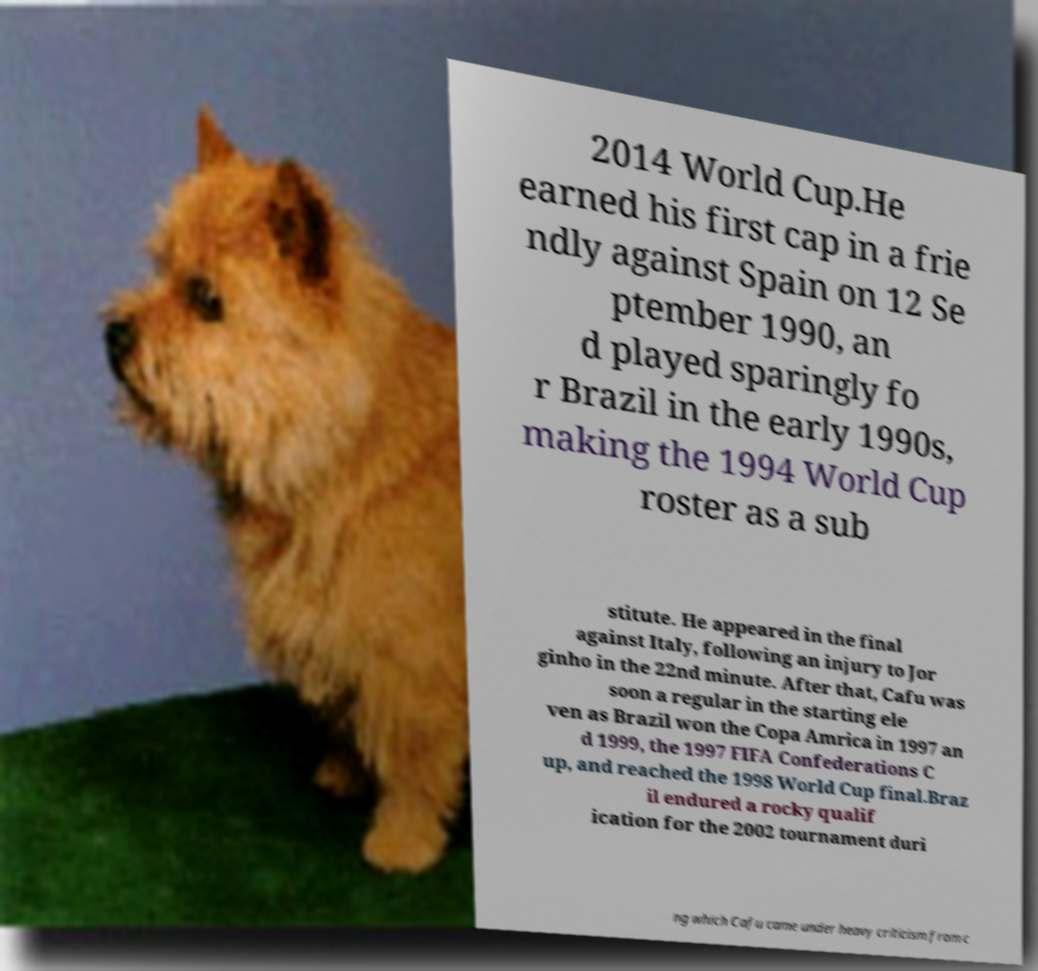I need the written content from this picture converted into text. Can you do that? 2014 World Cup.He earned his first cap in a frie ndly against Spain on 12 Se ptember 1990, an d played sparingly fo r Brazil in the early 1990s, making the 1994 World Cup roster as a sub stitute. He appeared in the final against Italy, following an injury to Jor ginho in the 22nd minute. After that, Cafu was soon a regular in the starting ele ven as Brazil won the Copa Amrica in 1997 an d 1999, the 1997 FIFA Confederations C up, and reached the 1998 World Cup final.Braz il endured a rocky qualif ication for the 2002 tournament duri ng which Cafu came under heavy criticism from c 